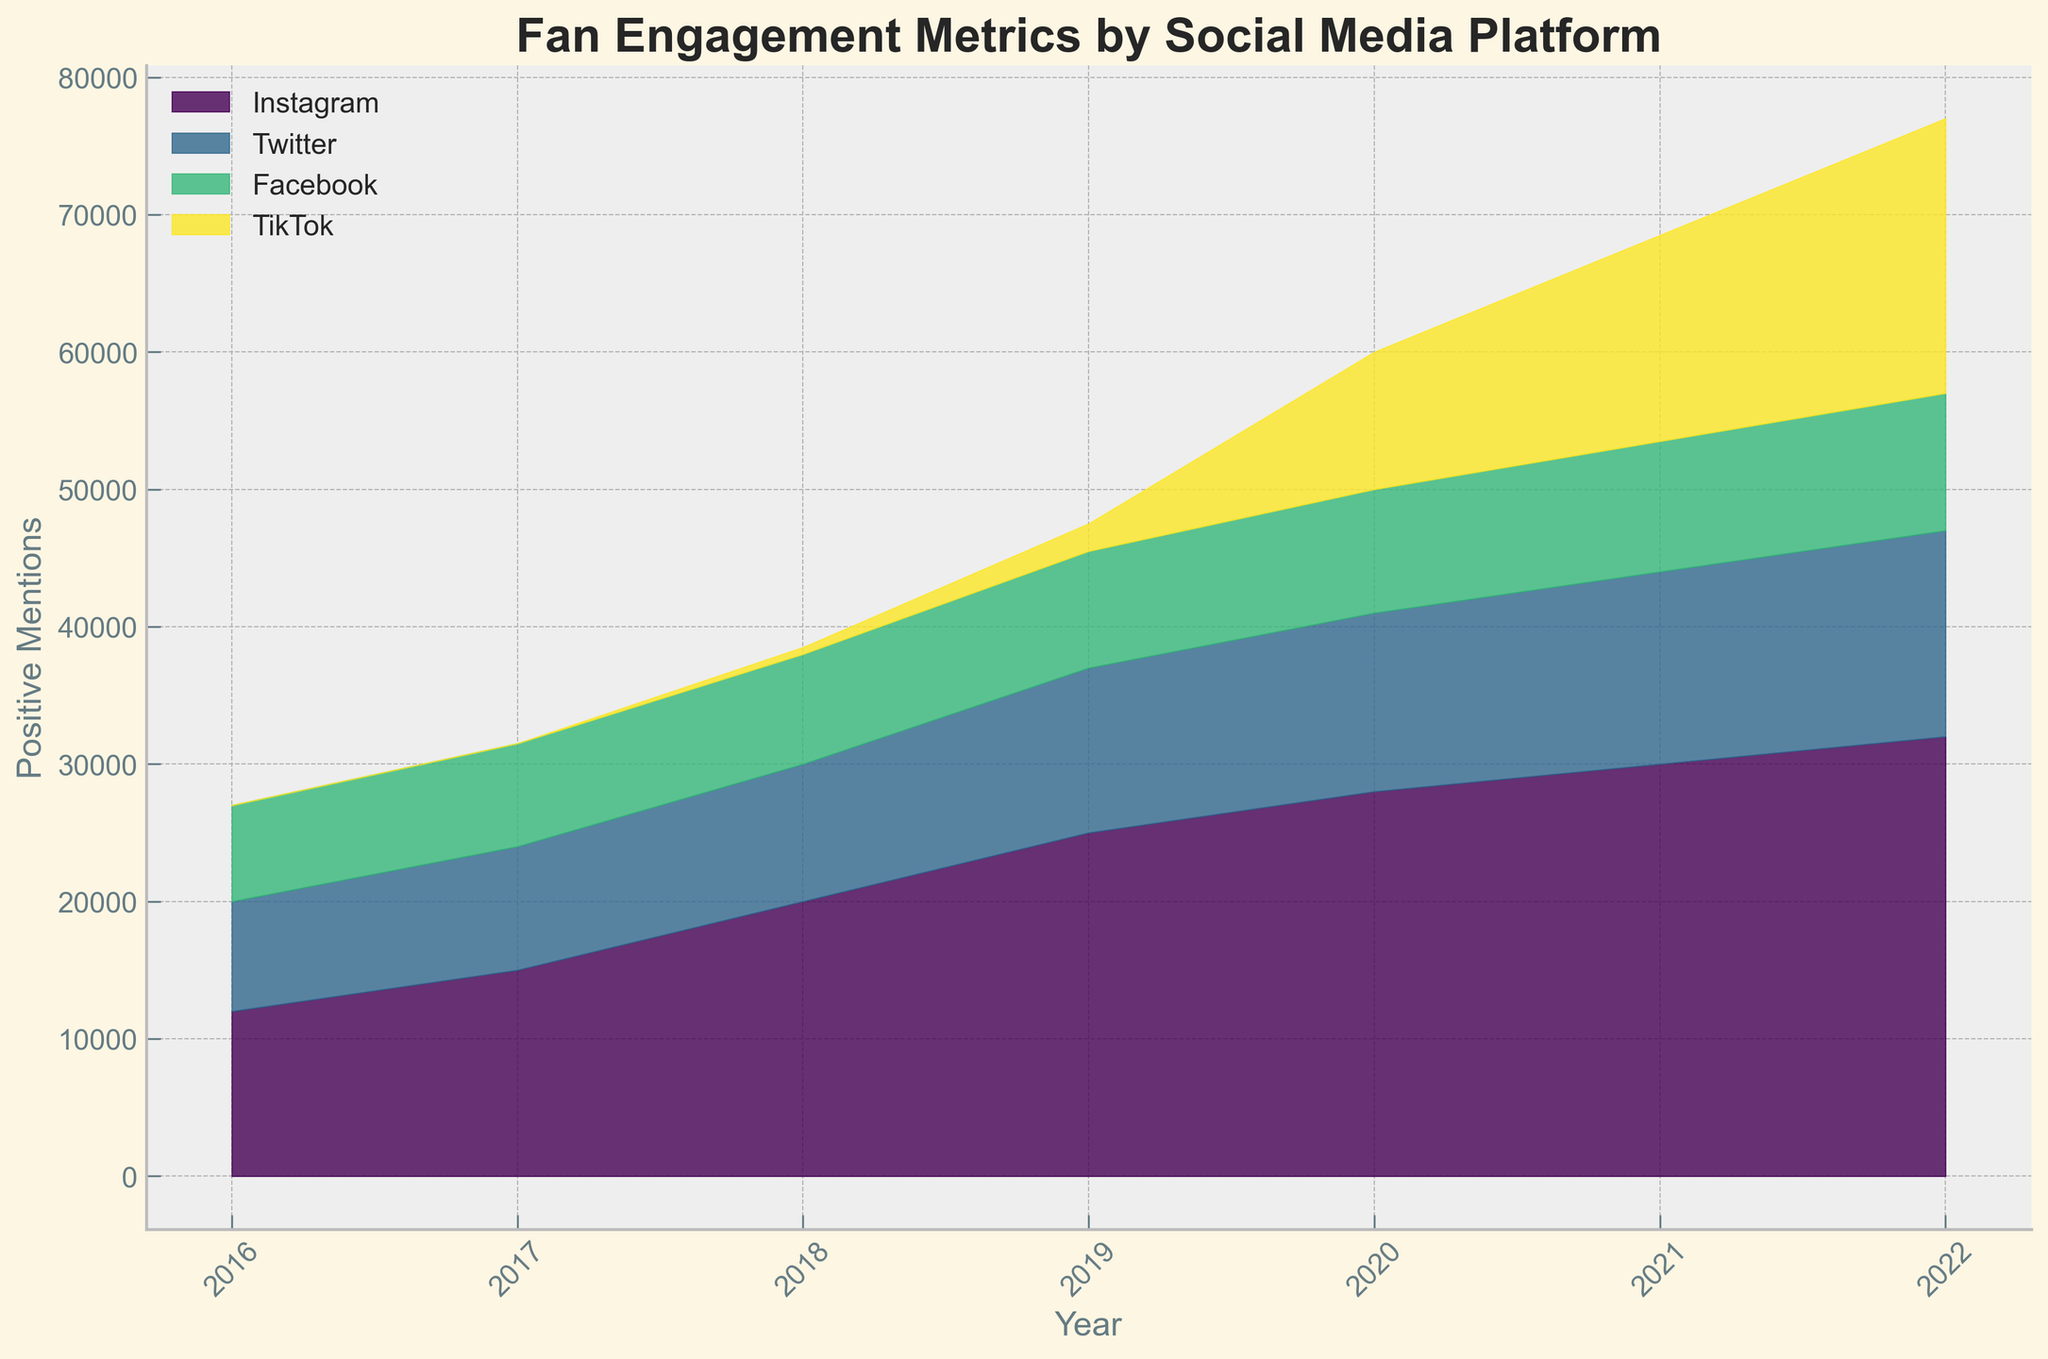What's the title of the plot? The title is generally located at the top of the plot, often in a larger font for emphasis. In this plot, the title reads "Fan Engagement Metrics by Social Media Platform," which suggests that the figure shows different metrics of fan engagement across various social media platforms over the years.
Answer: Fan Engagement Metrics by Social Media Platform What does the y-axis represent? The y-axis typically has a label that indicates what metric is being measured. In this plot, the label on the y-axis is "Positive Mentions," meaning it measures the number of positive mentions for each platform over the years.
Answer: Positive Mentions Which platform had the highest number of positive mentions in 2022? By examining the stream graph for the year 2022, you can see the height of the colored bands. Instagram is at the top, indicating it has the highest number of positive mentions for that year.
Answer: Instagram How did TikTok's positive mentions trend from 2018 to 2022? To understand the trend, observe the TikTok stream from 2018 to 2022 and note the change in its vertical size. TikTok's positive mentions significantly increased, as indicated by the enlarging band over these years.
Answer: Increased In which year did Instagram have the most significant increase in positive mentions compared to the previous year? To identify the year with the most significant increase for Instagram, observe the change in the height of the Instagram band between consecutive years. Between 2017 and 2018, Instagram's positive mentions had a notably large increase.
Answer: 2018 How does Twitter's overall positive mentions compare to Facebook's from 2016 to 2022? Compare the cumulative heights of the bands for Twitter and Facebook over all the years. Twitter's band appears slightly larger over all the years, indicating it has more positive mentions.
Answer: Twitter has more positive mentions Which platform saw its positive mentions decrease over any period? Look at the stream graphs for each platform. Twitter's positive mentions decreased between 2019 and 2020.
Answer: Twitter Given all platforms, which one had the least number of positive mentions in any year? Identify the smallest band in any given year. TikTok had the least positive mentions in 2018, as it only started to appear then with low values.
Answer: TikTok in 2018 Can we say Instagram had a consistent yearly increase in positive mentions? Check for consistency by following the Instagram band's height year by year. Instagram's positive mentions steadily increased each year from 2016 to 2022.
Answer: Yes 